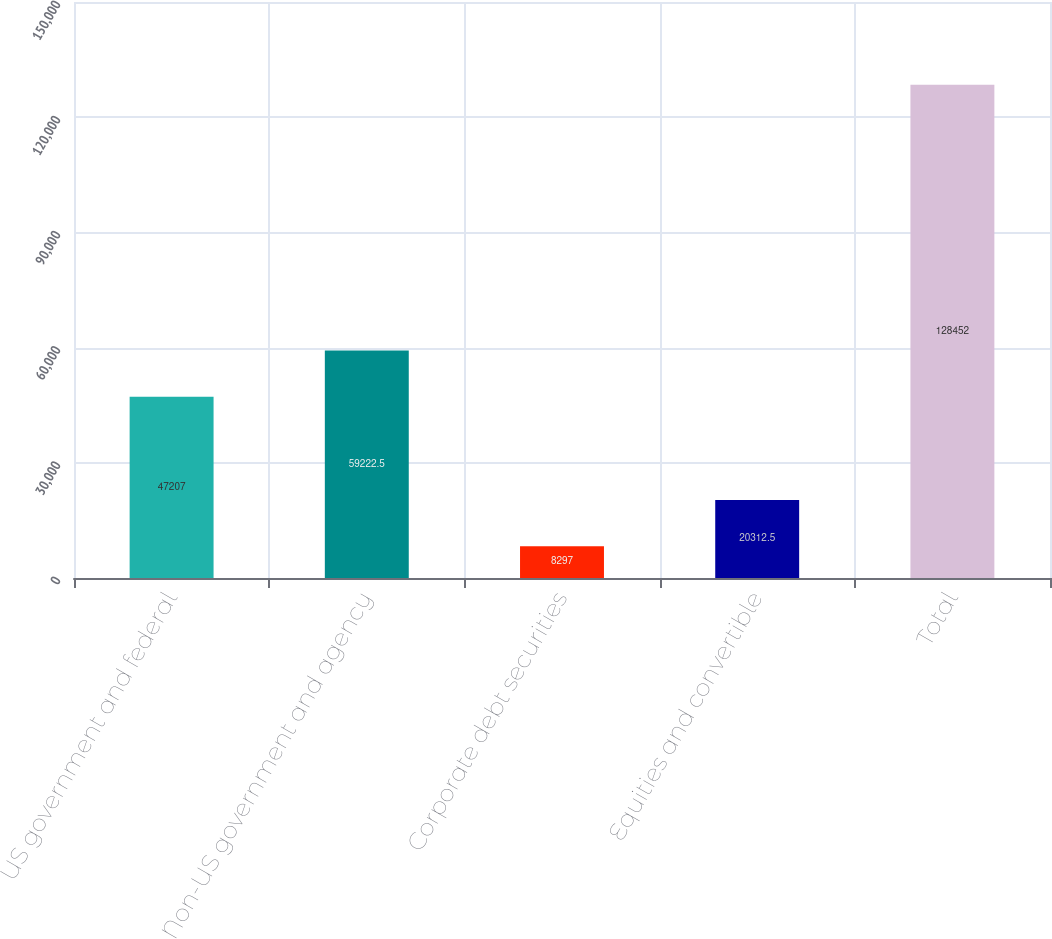<chart> <loc_0><loc_0><loc_500><loc_500><bar_chart><fcel>US government and federal<fcel>Non-US government and agency<fcel>Corporate debt securities<fcel>Equities and convertible<fcel>Total<nl><fcel>47207<fcel>59222.5<fcel>8297<fcel>20312.5<fcel>128452<nl></chart> 